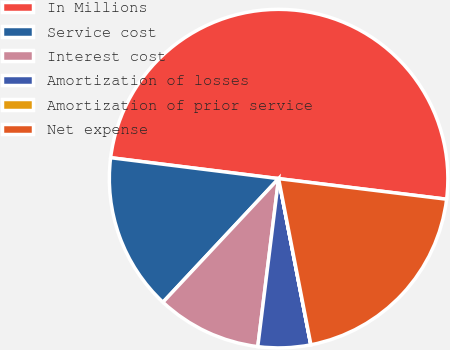Convert chart to OTSL. <chart><loc_0><loc_0><loc_500><loc_500><pie_chart><fcel>In Millions<fcel>Service cost<fcel>Interest cost<fcel>Amortization of losses<fcel>Amortization of prior service<fcel>Net expense<nl><fcel>49.97%<fcel>15.0%<fcel>10.01%<fcel>5.01%<fcel>0.01%<fcel>20.0%<nl></chart> 